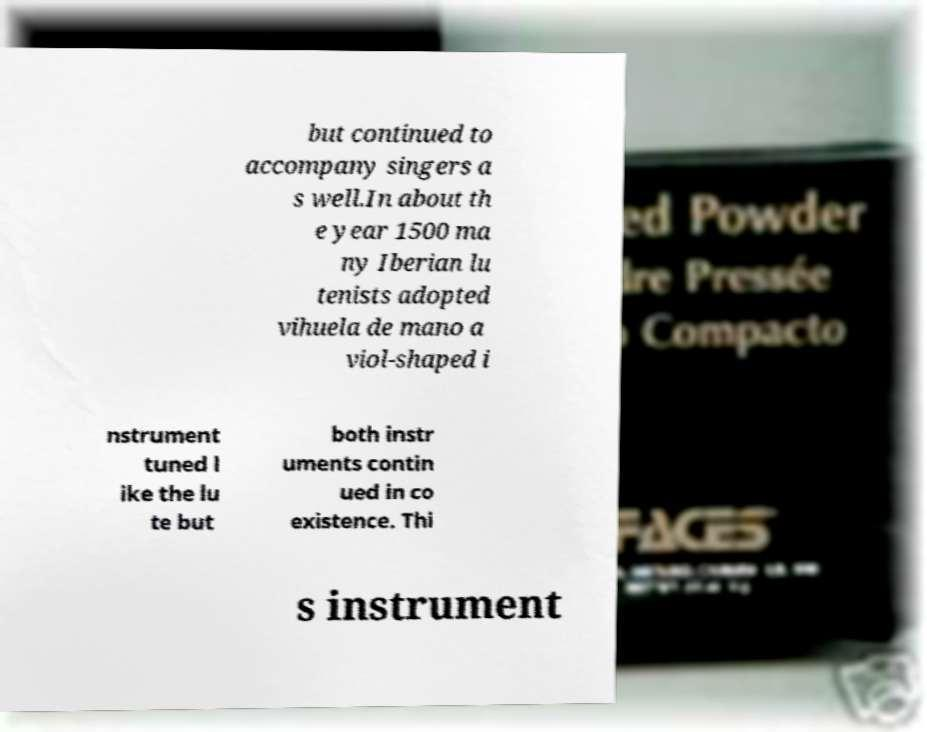There's text embedded in this image that I need extracted. Can you transcribe it verbatim? but continued to accompany singers a s well.In about th e year 1500 ma ny Iberian lu tenists adopted vihuela de mano a viol-shaped i nstrument tuned l ike the lu te but both instr uments contin ued in co existence. Thi s instrument 